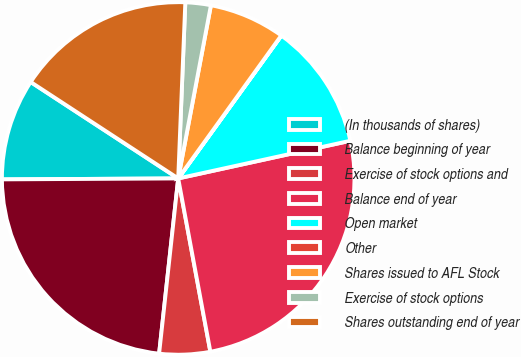Convert chart. <chart><loc_0><loc_0><loc_500><loc_500><pie_chart><fcel>(In thousands of shares)<fcel>Balance beginning of year<fcel>Exercise of stock options and<fcel>Balance end of year<fcel>Open market<fcel>Other<fcel>Shares issued to AFL Stock<fcel>Exercise of stock options<fcel>Shares outstanding end of year<nl><fcel>9.3%<fcel>23.19%<fcel>4.65%<fcel>25.51%<fcel>11.62%<fcel>0.01%<fcel>6.97%<fcel>2.33%<fcel>16.43%<nl></chart> 